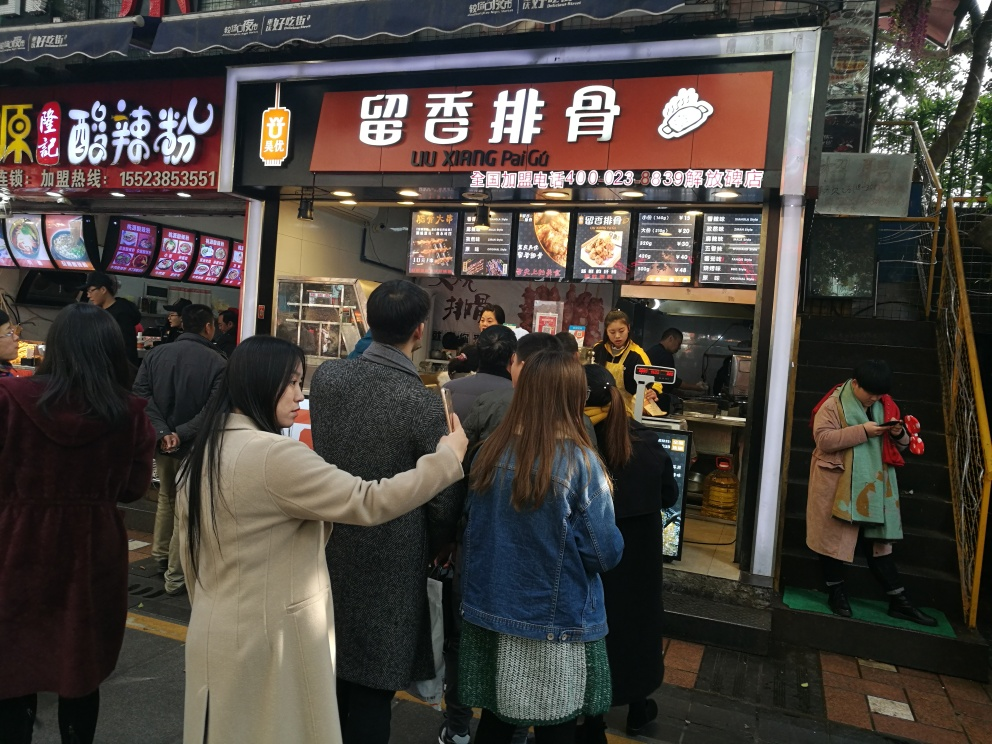Can you describe what kind of food is being sold at the stall in the image? The stall in the image appears to be selling various types of traditional Chinese food. The sign indicates a focus on dishes like dumplings and noodle soups. We can also observe images of the food being offered, showcasing a variety of enticing options. 